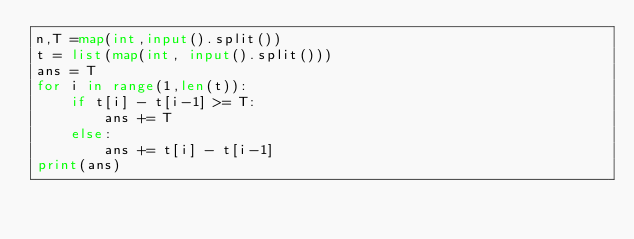Convert code to text. <code><loc_0><loc_0><loc_500><loc_500><_Python_>n,T =map(int,input().split())
t = list(map(int, input().split()))
ans = T
for i in range(1,len(t)):
    if t[i] - t[i-1] >= T:
        ans += T
    else:
        ans += t[i] - t[i-1]
print(ans)</code> 